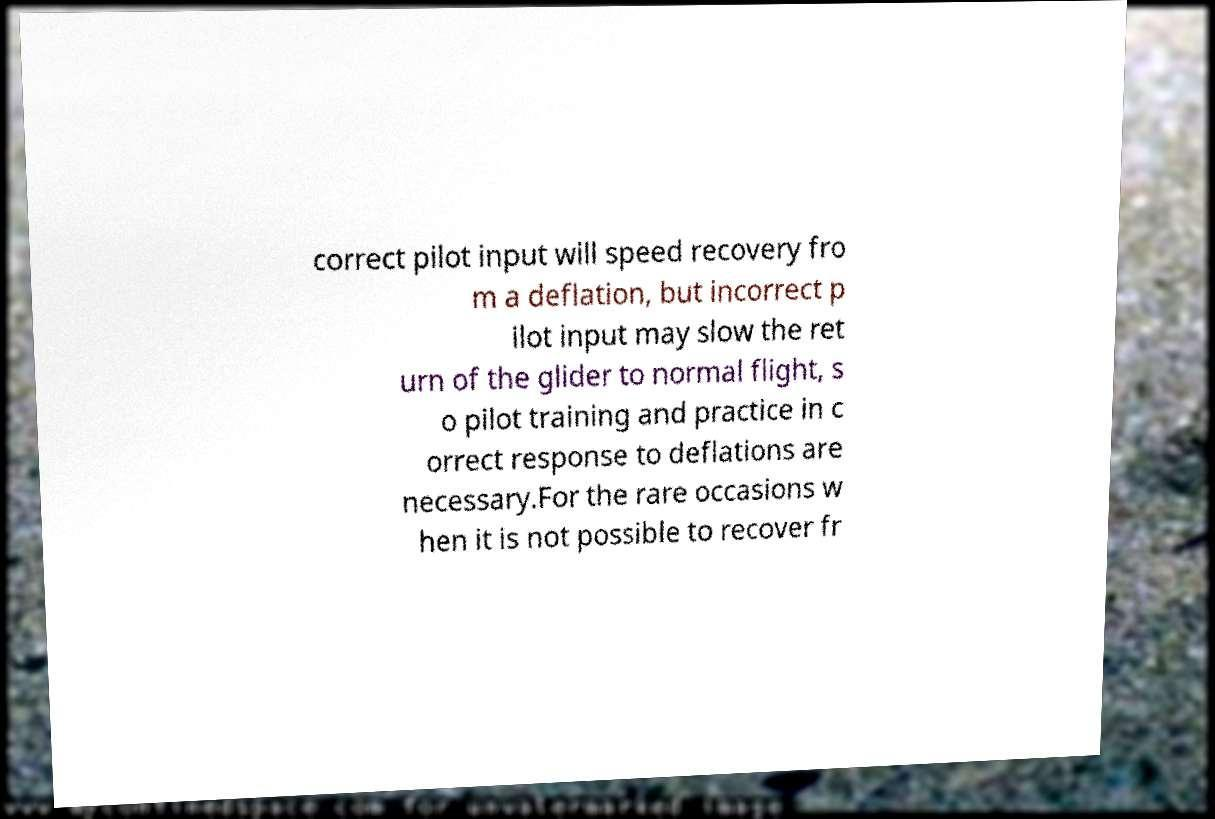Could you assist in decoding the text presented in this image and type it out clearly? correct pilot input will speed recovery fro m a deflation, but incorrect p ilot input may slow the ret urn of the glider to normal flight, s o pilot training and practice in c orrect response to deflations are necessary.For the rare occasions w hen it is not possible to recover fr 